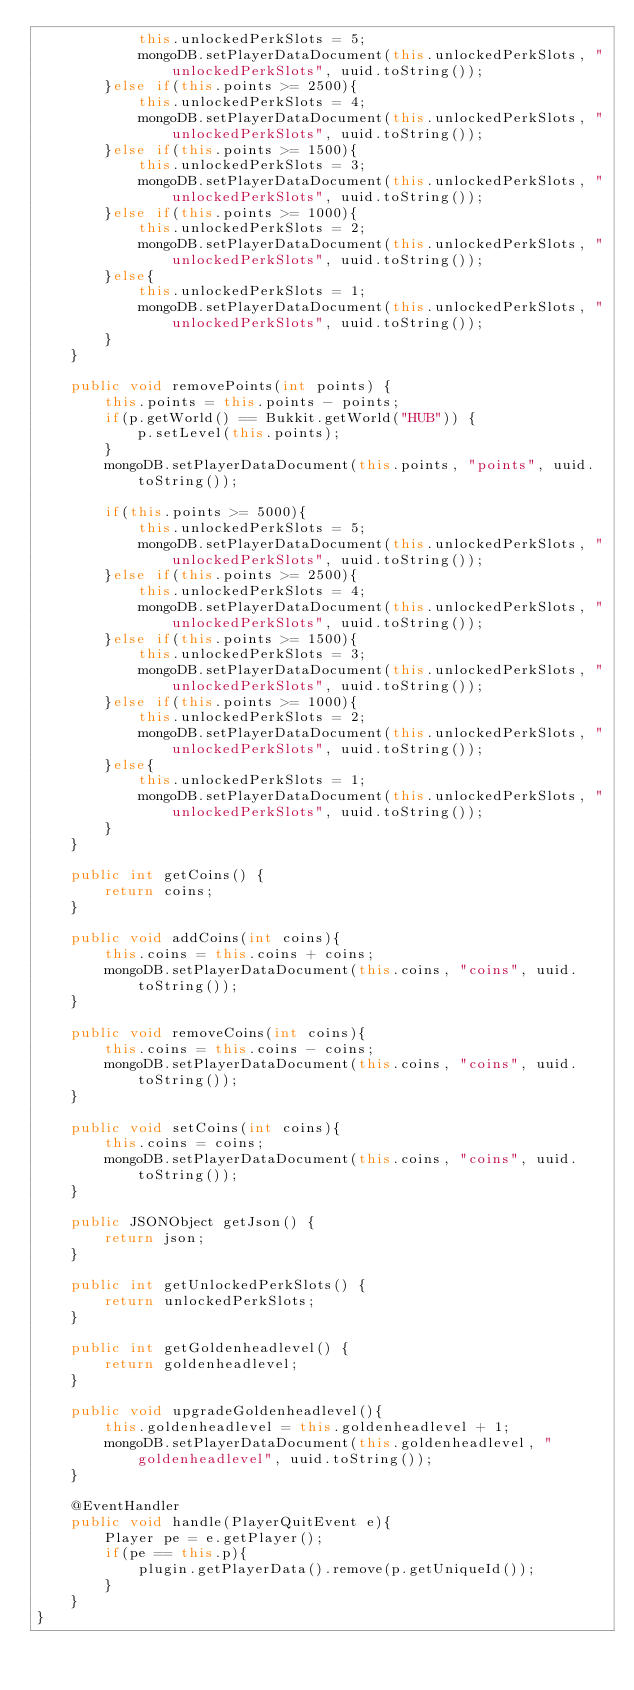<code> <loc_0><loc_0><loc_500><loc_500><_Java_>            this.unlockedPerkSlots = 5;
            mongoDB.setPlayerDataDocument(this.unlockedPerkSlots, "unlockedPerkSlots", uuid.toString());
        }else if(this.points >= 2500){
            this.unlockedPerkSlots = 4;
            mongoDB.setPlayerDataDocument(this.unlockedPerkSlots, "unlockedPerkSlots", uuid.toString());
        }else if(this.points >= 1500){
            this.unlockedPerkSlots = 3;
            mongoDB.setPlayerDataDocument(this.unlockedPerkSlots, "unlockedPerkSlots", uuid.toString());
        }else if(this.points >= 1000){
            this.unlockedPerkSlots = 2;
            mongoDB.setPlayerDataDocument(this.unlockedPerkSlots, "unlockedPerkSlots", uuid.toString());
        }else{
            this.unlockedPerkSlots = 1;
            mongoDB.setPlayerDataDocument(this.unlockedPerkSlots, "unlockedPerkSlots", uuid.toString());
        }
    }

    public void removePoints(int points) {
        this.points = this.points - points;
        if(p.getWorld() == Bukkit.getWorld("HUB")) {
            p.setLevel(this.points);
        }
        mongoDB.setPlayerDataDocument(this.points, "points", uuid.toString());

        if(this.points >= 5000){
            this.unlockedPerkSlots = 5;
            mongoDB.setPlayerDataDocument(this.unlockedPerkSlots, "unlockedPerkSlots", uuid.toString());
        }else if(this.points >= 2500){
            this.unlockedPerkSlots = 4;
            mongoDB.setPlayerDataDocument(this.unlockedPerkSlots, "unlockedPerkSlots", uuid.toString());
        }else if(this.points >= 1500){
            this.unlockedPerkSlots = 3;
            mongoDB.setPlayerDataDocument(this.unlockedPerkSlots, "unlockedPerkSlots", uuid.toString());
        }else if(this.points >= 1000){
            this.unlockedPerkSlots = 2;
            mongoDB.setPlayerDataDocument(this.unlockedPerkSlots, "unlockedPerkSlots", uuid.toString());
        }else{
            this.unlockedPerkSlots = 1;
            mongoDB.setPlayerDataDocument(this.unlockedPerkSlots, "unlockedPerkSlots", uuid.toString());
        }
    }

    public int getCoins() {
        return coins;
    }

    public void addCoins(int coins){
        this.coins = this.coins + coins;
        mongoDB.setPlayerDataDocument(this.coins, "coins", uuid.toString());
    }

    public void removeCoins(int coins){
        this.coins = this.coins - coins;
        mongoDB.setPlayerDataDocument(this.coins, "coins", uuid.toString());
    }

    public void setCoins(int coins){
        this.coins = coins;
        mongoDB.setPlayerDataDocument(this.coins, "coins", uuid.toString());
    }

    public JSONObject getJson() {
        return json;
    }

    public int getUnlockedPerkSlots() {
        return unlockedPerkSlots;
    }

    public int getGoldenheadlevel() {
        return goldenheadlevel;
    }

    public void upgradeGoldenheadlevel(){
        this.goldenheadlevel = this.goldenheadlevel + 1;
        mongoDB.setPlayerDataDocument(this.goldenheadlevel, "goldenheadlevel", uuid.toString());
    }

    @EventHandler
    public void handle(PlayerQuitEvent e){
        Player pe = e.getPlayer();
        if(pe == this.p){
            plugin.getPlayerData().remove(p.getUniqueId());
        }
    }
}
</code> 